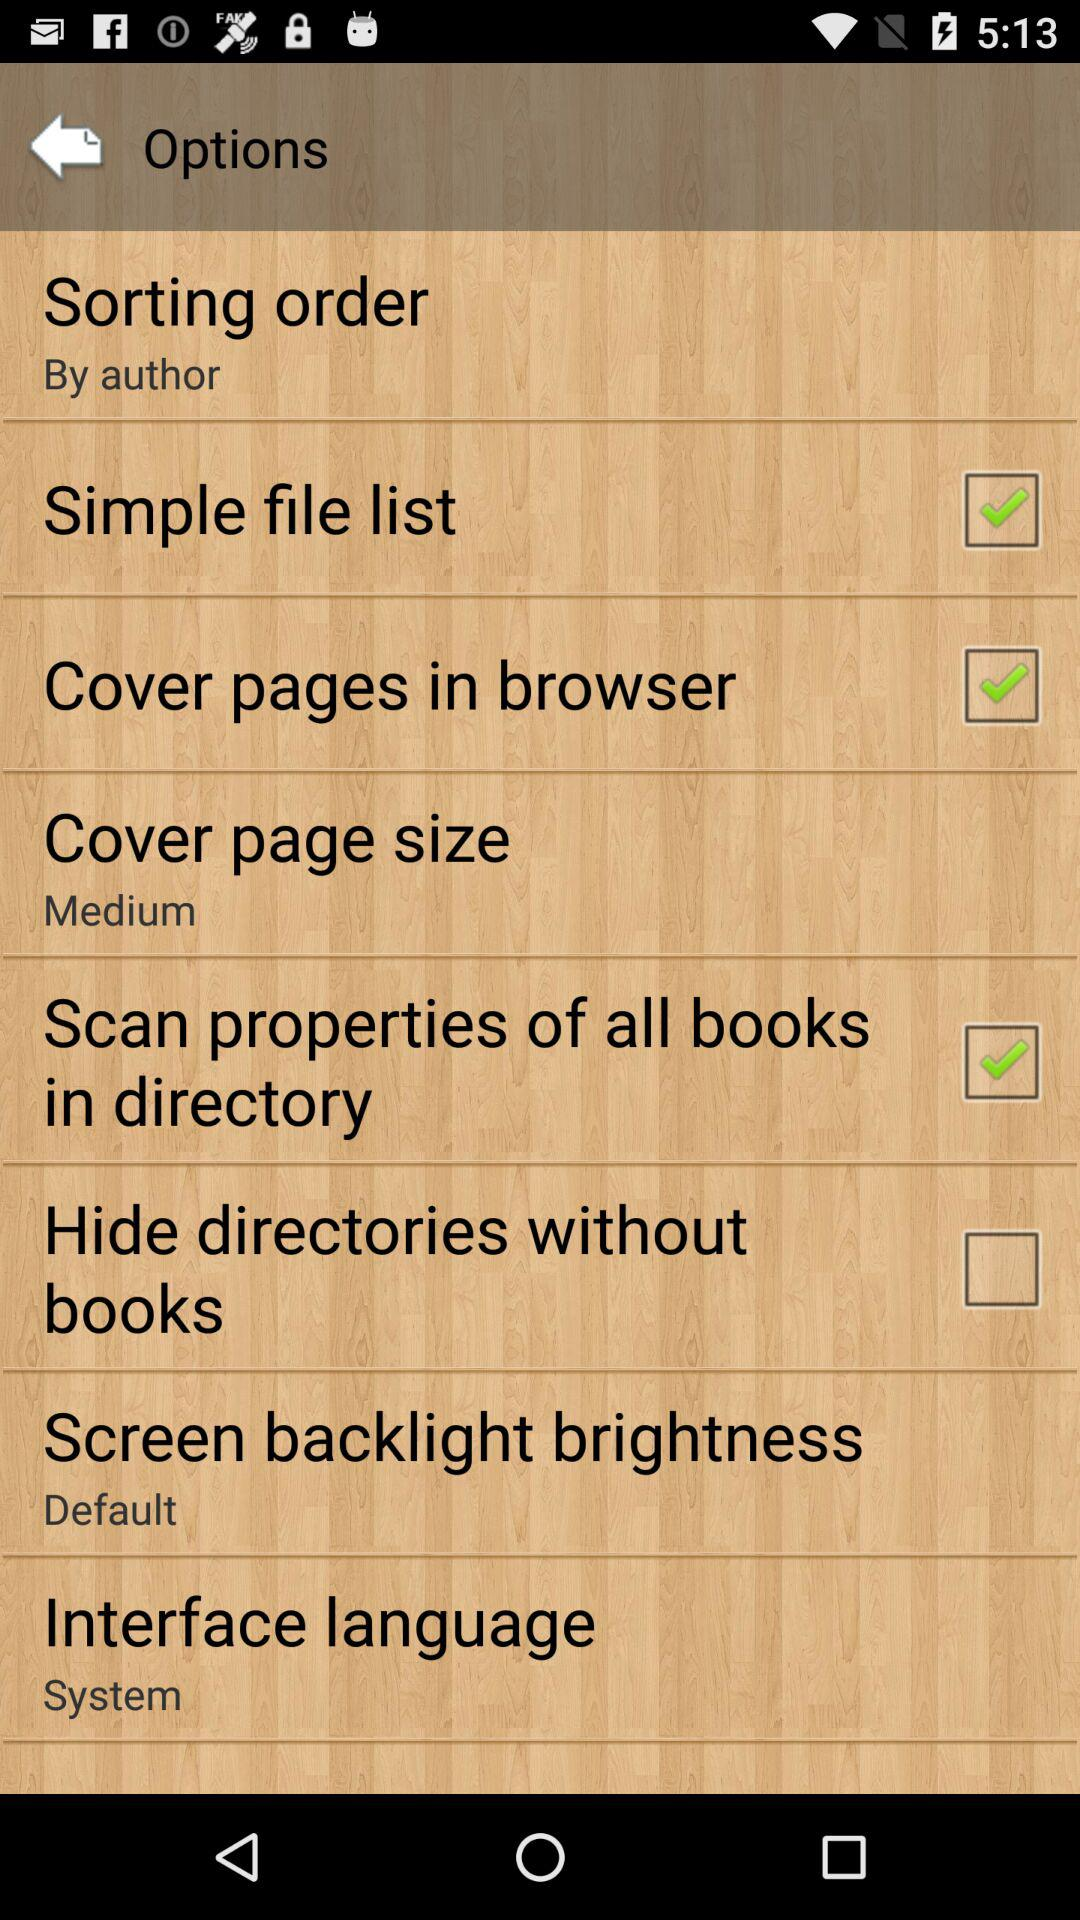What is the setting for sorting order? The setting for sorting order is "By author". 